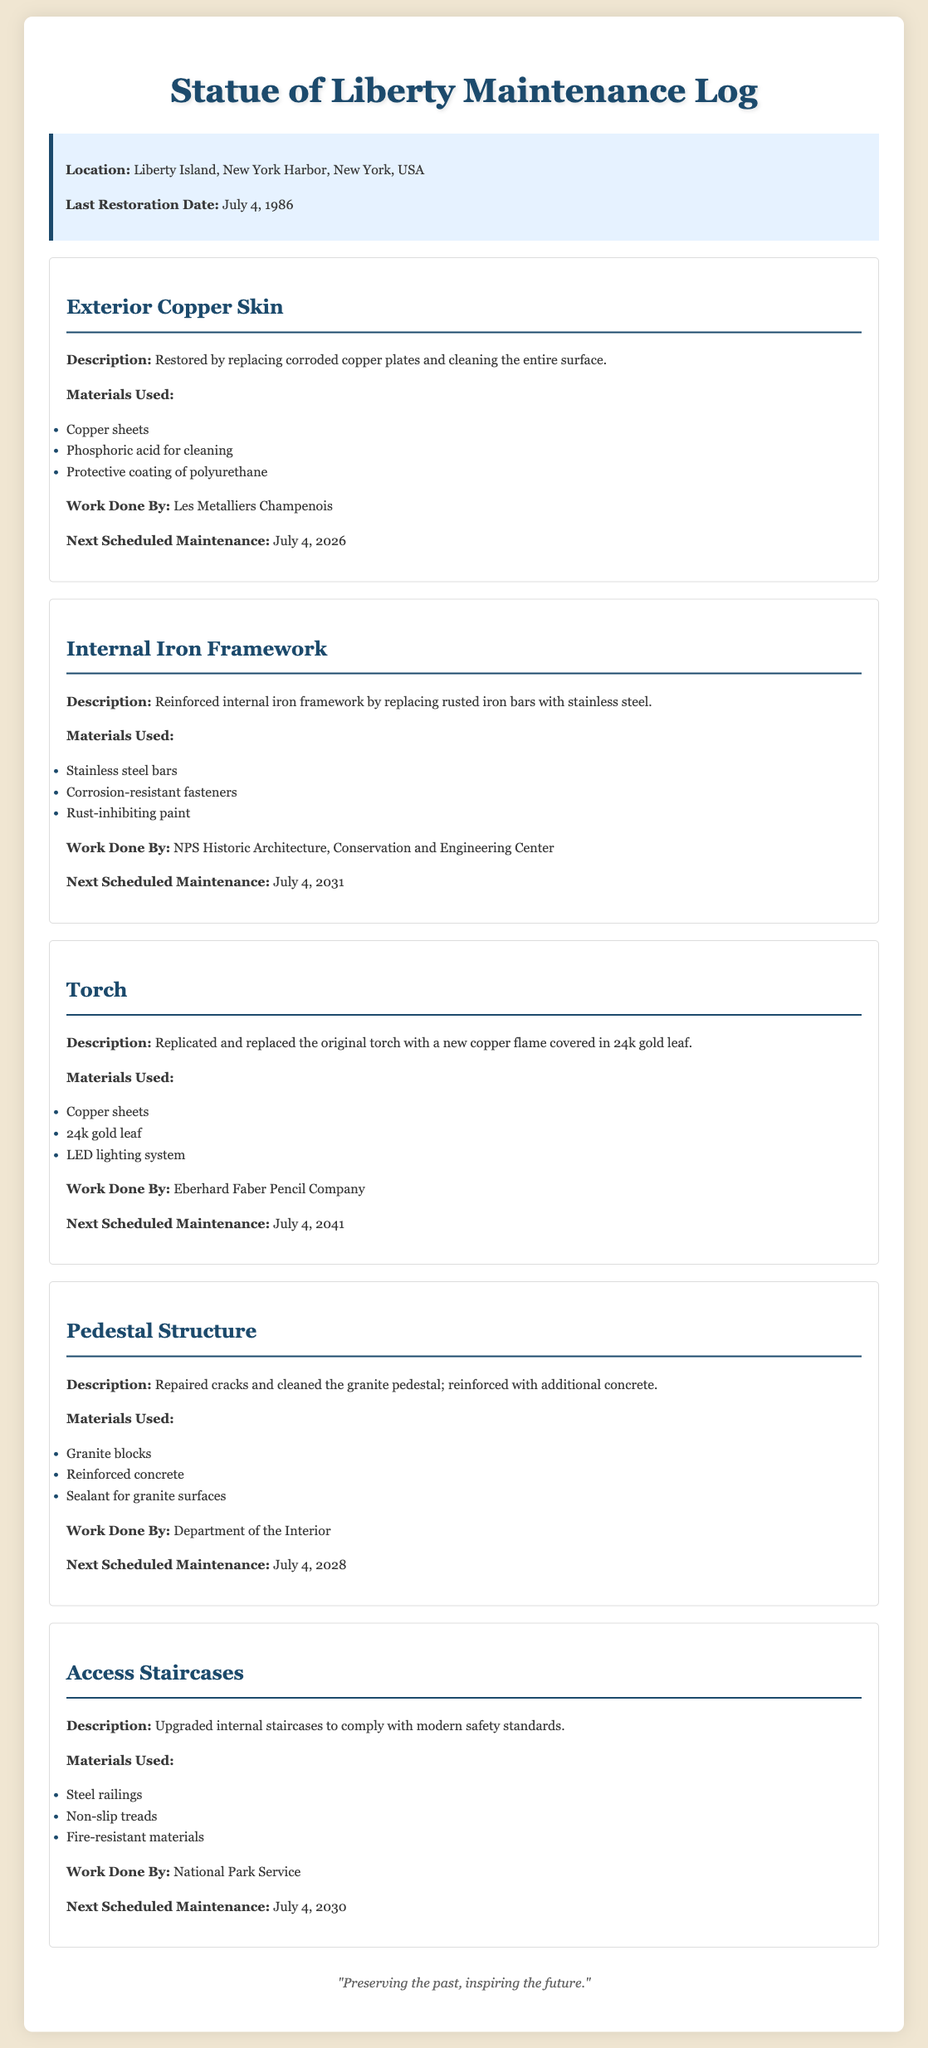What is the location of the monument? The location of the monument is stated in the information section of the log.
Answer: Liberty Island, New York Harbor, New York, USA When was the last restoration of the Statue of Liberty? The last restoration date is explicitly mentioned in the log.
Answer: July 4, 1986 What materials were used for the restoration of the Internal Iron Framework? The materials used are listed under the "Internal Iron Framework" section of the log.
Answer: Stainless steel bars, corrosion-resistant fasteners, rust-inhibiting paint Who performed the work on the Torch? The work done by section mentions who was responsible for the task on the Torch.
Answer: Eberhard Faber Pencil Company What is the next scheduled maintenance date for the Pedestal Structure? The next scheduled maintenance is indicated in the maintenance section of the Pedestal Structure.
Answer: July 4, 2028 Why were stainless steel bars used in the Internal Iron Framework restoration? The reasoning draws from the context of replacing rusted iron bars mentioned in the description.
Answer: To replace rusted iron bars How often is maintenance scheduled for the Exterior Copper Skin? The frequency of maintenance is defined by the next scheduled maintenance noted in that section of the log.
Answer: Every 5 years What type of coating was used after cleaning the Exterior Copper Skin? The specific protective measure taken after cleaning is mentioned under that section’s details.
Answer: Polyurethane What significant change was made to the Torch during the restoration? This query requires summarizing the main improvement stated in the Torch section.
Answer: New copper flame covered in 24k gold leaf 